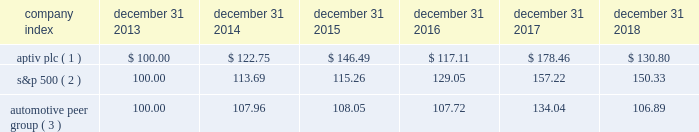Part ii item 5 .
Market for registrant 2019s common equity , related stockholder matters and issuer purchases of equity securities our ordinary shares have been publicly traded since november 17 , 2011 when our ordinary shares were listed and began trading on the new york stock exchange ( 201cnyse 201d ) under the symbol 201cdlph . 201d on december 4 , 2017 , following the spin-off of delphi technologies , the company changed its name to aptiv plc and its nyse symbol to 201captv . 201d as of january 25 , 2019 , there were 2 shareholders of record of our ordinary shares .
The following graph reflects the comparative changes in the value from december 31 , 2013 through december 31 , 2018 , assuming an initial investment of $ 100 and the reinvestment of dividends , if any in ( 1 ) our ordinary shares , ( 2 ) the s&p 500 index and ( 3 ) the automotive peer group .
Historical share prices of our ordinary shares have been adjusted to reflect the separation .
Historical performance may not be indicative of future shareholder returns .
Stock performance graph * $ 100 invested on december 31 , 2013 in our stock or in the relevant index , including reinvestment of dividends .
Fiscal year ended december 31 , 2018 .
( 1 ) aptiv plc , adjusted for the distribution of delphi technologies on december 4 , 2017 ( 2 ) s&p 500 2013 standard & poor 2019s 500 total return index ( 3 ) automotive peer group 2013 adient plc , american axle & manufacturing holdings inc , aptiv plc , borgwarner inc , cooper tire & rubber co , cooper- standard holdings inc , dana inc , dorman products inc , ford motor co , garrett motion inc. , general motors co , gentex corp , gentherm inc , genuine parts co , goodyear tire & rubber co , lear corp , lkq corp , meritor inc , motorcar parts of america inc , standard motor products inc , stoneridge inc , superior industries international inc , tenneco inc , tesla inc , tower international inc , visteon corp , wabco holdings inc company index december 31 , december 31 , december 31 , december 31 , december 31 , december 31 .

What is the difference in percentage performance for aptiv plc versus the s&p 500 for the five year period ending december 31 2018? 
Computations: (((130.80 - 100) / 100) - ((150.33 - 100) / 100))
Answer: -0.1953. 